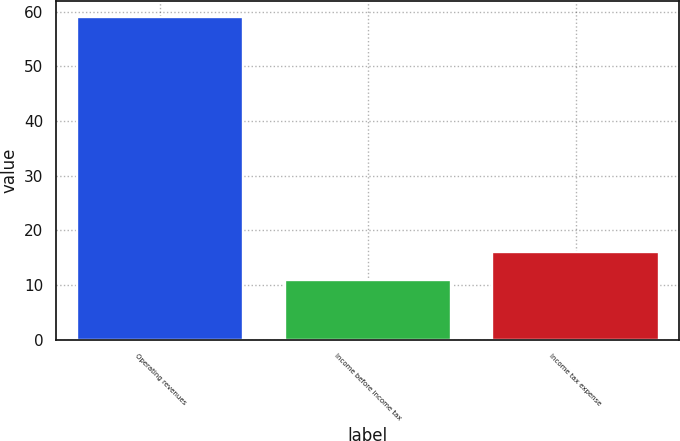Convert chart to OTSL. <chart><loc_0><loc_0><loc_500><loc_500><bar_chart><fcel>Operating revenues<fcel>Income before income tax<fcel>Income tax expense<nl><fcel>59<fcel>11<fcel>16<nl></chart> 